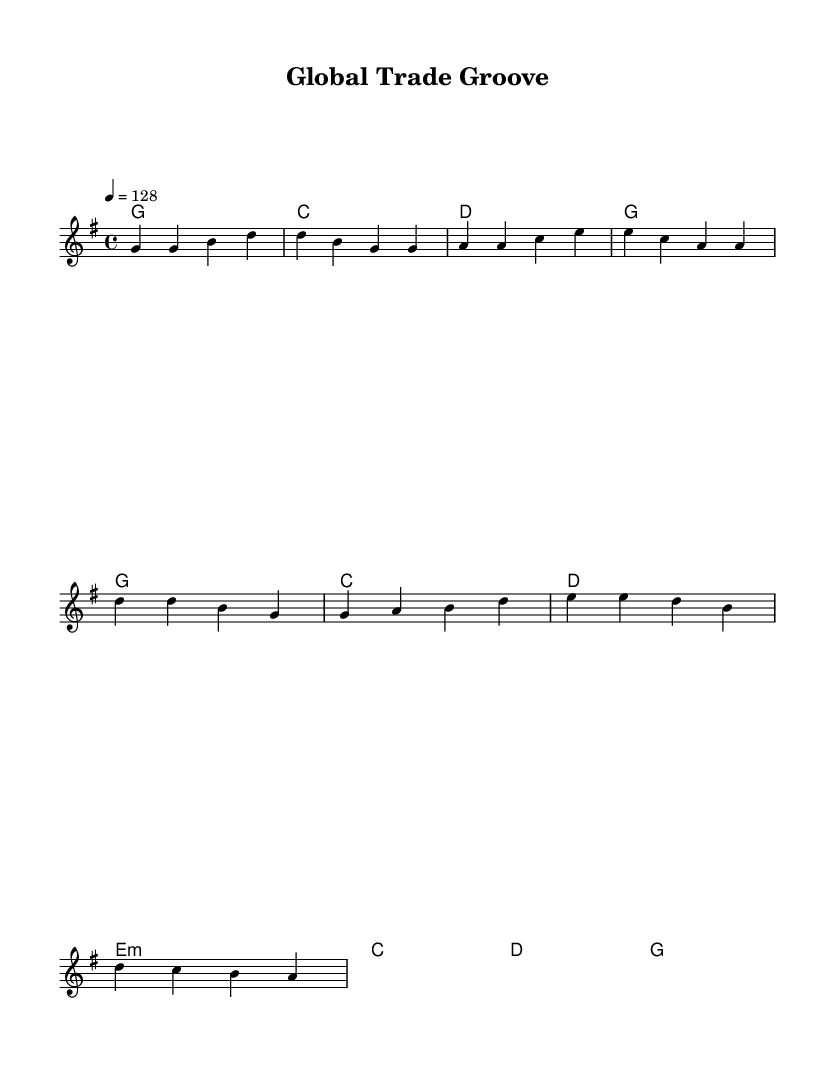What is the key signature of this music? The key signature is G major, which has one sharp (F#).
Answer: G major What is the time signature of the piece? The time signature is 4/4, meaning there are four beats in each measure.
Answer: 4/4 What is the tempo of this piece? The tempo marking indicates a speed of 128 beats per minute.
Answer: 128 What chords are used in the verse? The chords in the verse are G, C, D, and G, as seen in the chord mode section.
Answer: G, C, D How many measures are there in the chorus? The chorus consists of four measures as indicated by the grouping of the notes.
Answer: 4 How does the melody in the chorus differ from the verse? The melody in the chorus primarily uses different notes in comparison to the verse, creating a contrast that is common in country rock themes. The chorus emphasizes D and E prominently.
Answer: Different notes What theme does this piece convey? The piece conveys cultural exchange and global connections, as evidenced by its title "Global Trade Groove" and upbeat style often found in country rock.
Answer: Cultural exchange 